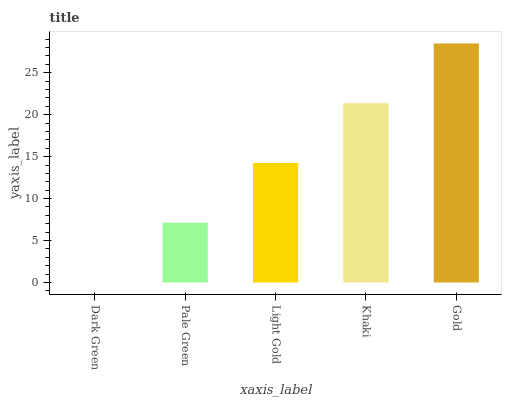Is Dark Green the minimum?
Answer yes or no. Yes. Is Gold the maximum?
Answer yes or no. Yes. Is Pale Green the minimum?
Answer yes or no. No. Is Pale Green the maximum?
Answer yes or no. No. Is Pale Green greater than Dark Green?
Answer yes or no. Yes. Is Dark Green less than Pale Green?
Answer yes or no. Yes. Is Dark Green greater than Pale Green?
Answer yes or no. No. Is Pale Green less than Dark Green?
Answer yes or no. No. Is Light Gold the high median?
Answer yes or no. Yes. Is Light Gold the low median?
Answer yes or no. Yes. Is Khaki the high median?
Answer yes or no. No. Is Dark Green the low median?
Answer yes or no. No. 